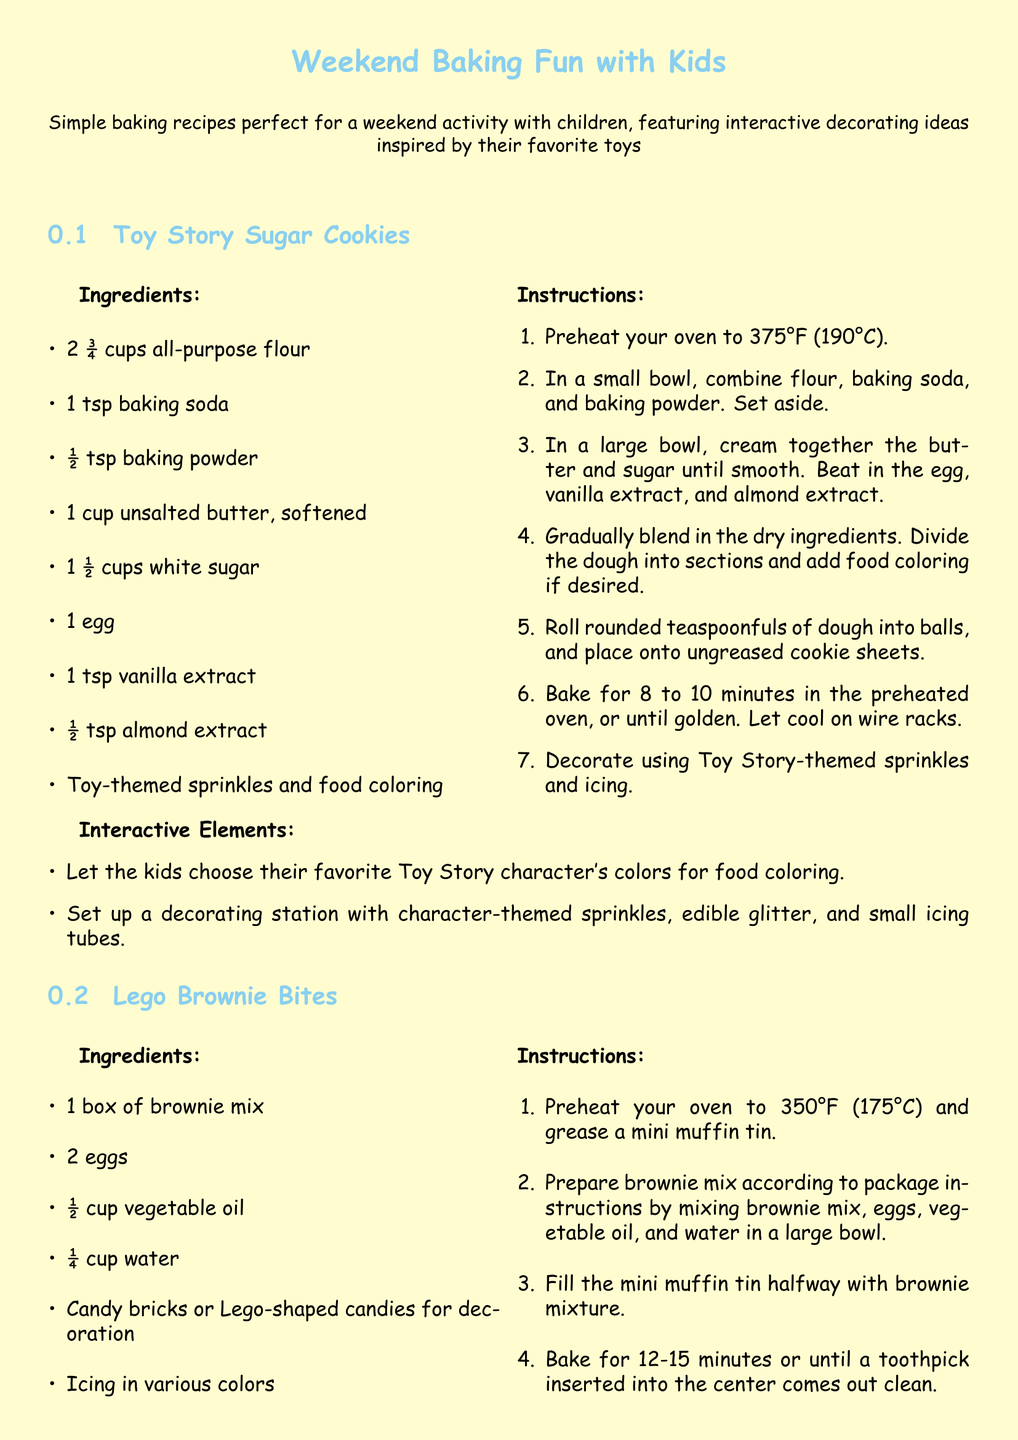What is the first recipe mentioned? The first recipe listed in the document is Toy Story Sugar Cookies.
Answer: Toy Story Sugar Cookies How many eggs are needed for the Lego Brownie Bites? The Lego Brownie Bites recipe requires 2 eggs.
Answer: 2 eggs What temperature should the oven be preheated to for sugar cookies? The document specifies that the oven should be preheated to 375°F for the sugar cookies.
Answer: 375°F What interactive element is suggested for the sugar cookies? The interactive element for the sugar cookies includes choosing Toy Story character colors for food coloring.
Answer: Choosing Toy Story character colors for food coloring How long should the Lego Brownie Bites bake? The document states that the Lego Brownie Bites should bake for 12-15 minutes.
Answer: 12-15 minutes What type of tin is used for baking the brownie bites? The recipe for Lego Brownie Bites indicates a mini muffin tin is used.
Answer: Mini muffin tin What is a recommended decoration for the sugar cookies? The recommended decoration for the sugar cookies includes Toy Story-themed sprinkles.
Answer: Toy Story-themed sprinkles What is the main baking mix used in the Lego Brownie Bites recipe? The main baking mix used is a box of brownie mix.
Answer: Box of brownie mix 